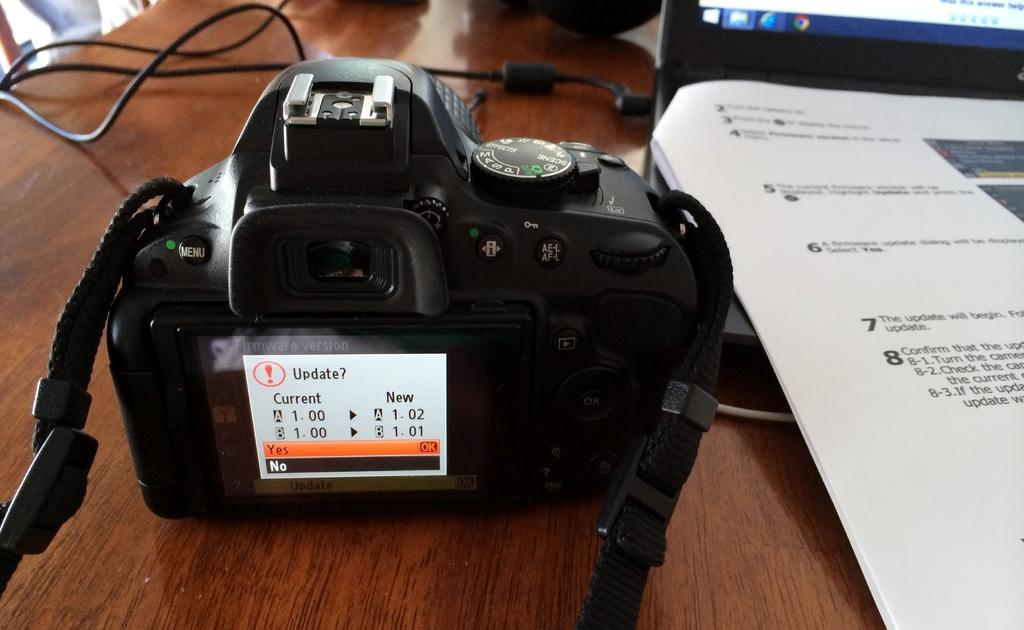What device is visible in the image? There is a camera in the image. Where is the camera located? The camera is on a table. What other electronic device is present in the image? There is a laptop in the image. Where is the laptop located? The laptop is on a table. What is on top of the laptop? There are papers on the laptop. What is connected to the laptop? There are wires connected to the laptop. What type of pest can be seen crawling on the stage in the image? There is no stage or pest present in the image; it features a camera and a laptop on a table. 